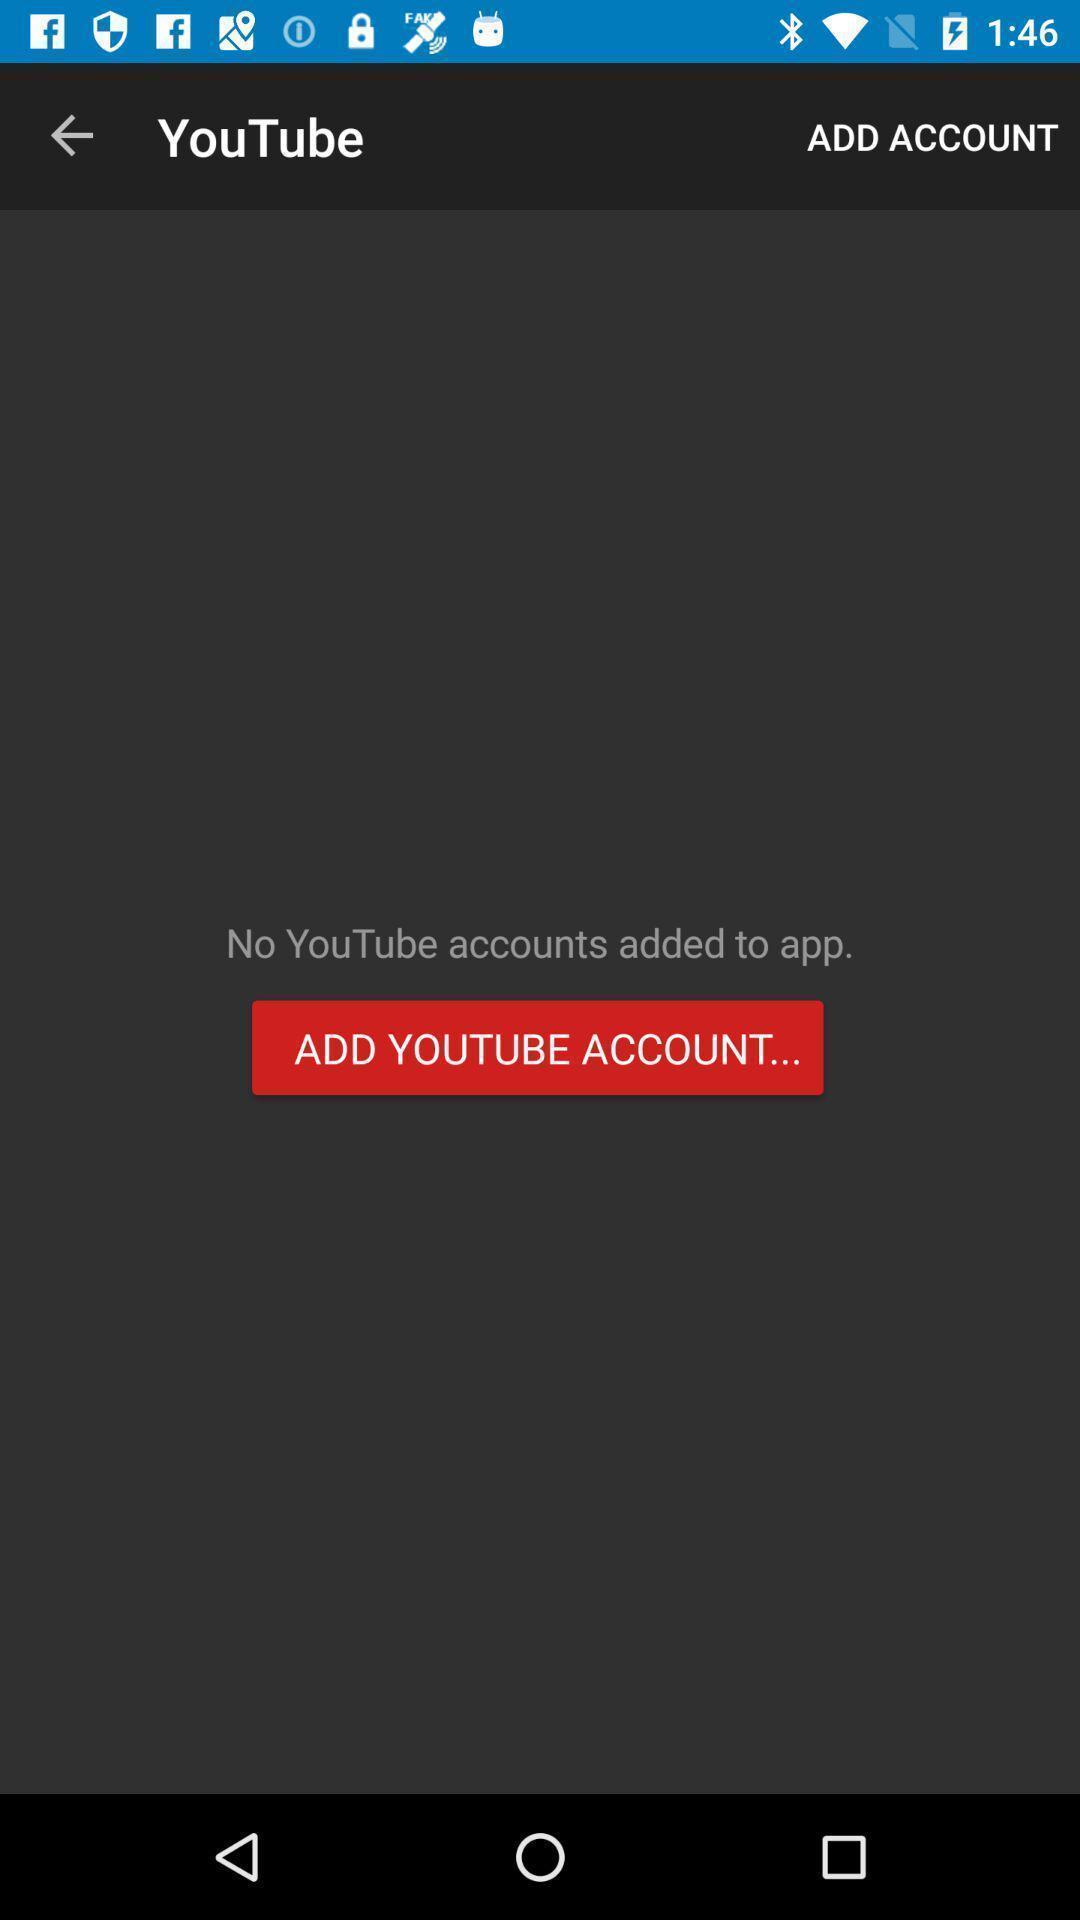Explain what's happening in this screen capture. Page showing add account in app. 